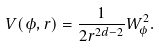Convert formula to latex. <formula><loc_0><loc_0><loc_500><loc_500>V ( \phi , r ) = \frac { 1 } { 2 r ^ { 2 d - 2 } } W _ { \phi } ^ { 2 } .</formula> 